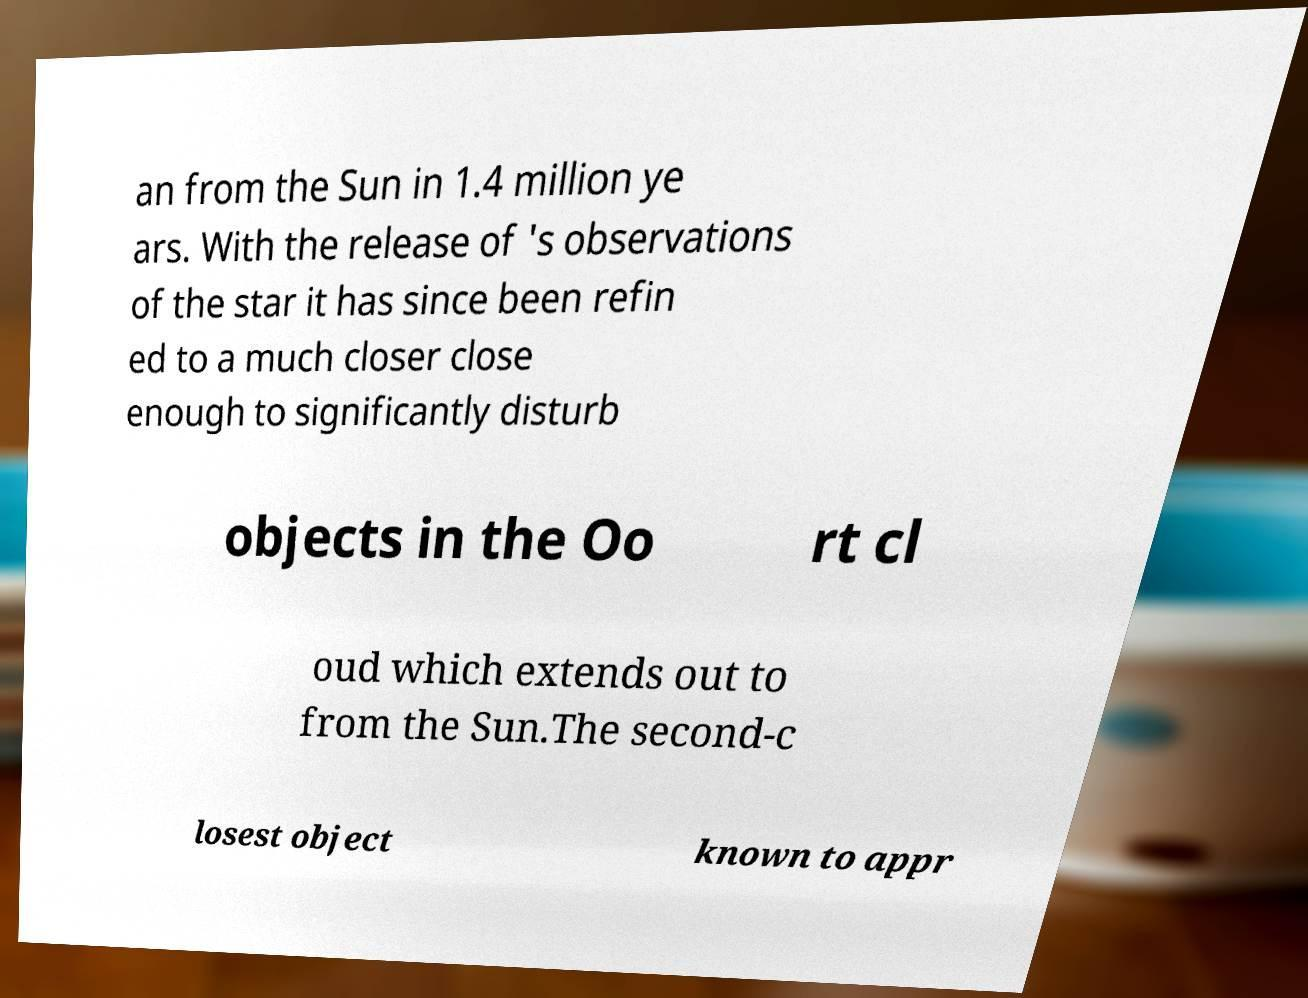I need the written content from this picture converted into text. Can you do that? an from the Sun in 1.4 million ye ars. With the release of 's observations of the star it has since been refin ed to a much closer close enough to significantly disturb objects in the Oo rt cl oud which extends out to from the Sun.The second-c losest object known to appr 